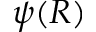<formula> <loc_0><loc_0><loc_500><loc_500>\psi ( R )</formula> 